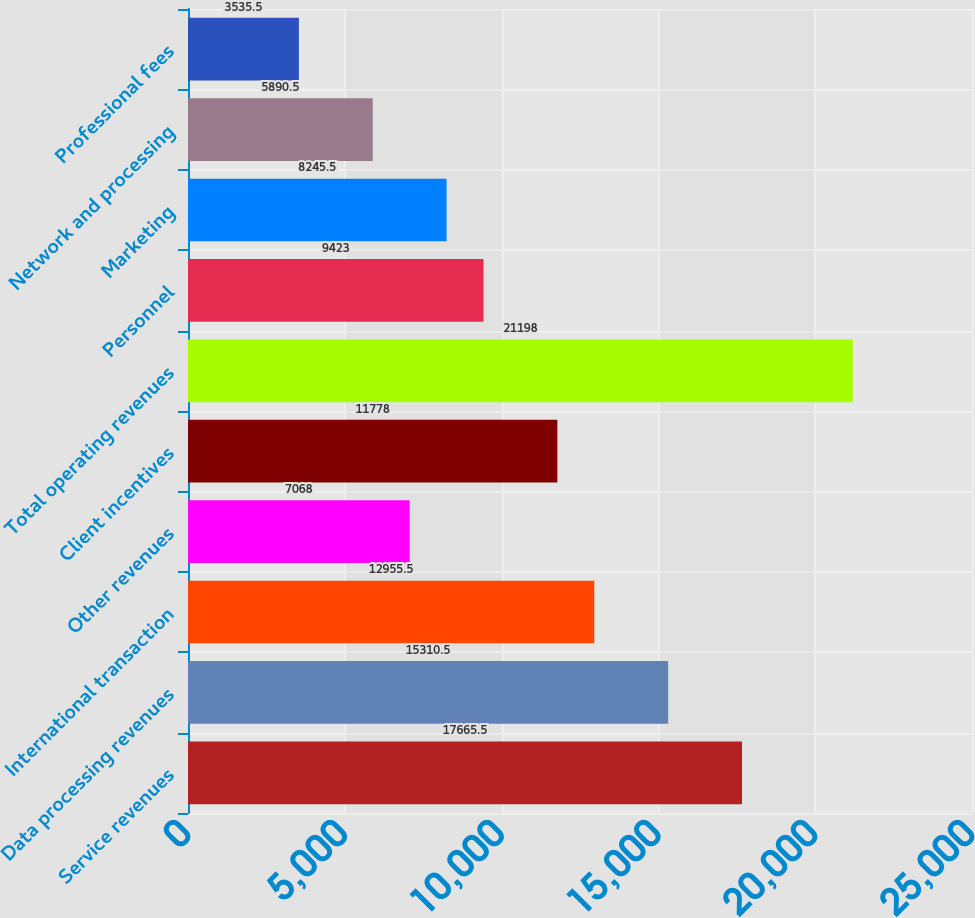Convert chart. <chart><loc_0><loc_0><loc_500><loc_500><bar_chart><fcel>Service revenues<fcel>Data processing revenues<fcel>International transaction<fcel>Other revenues<fcel>Client incentives<fcel>Total operating revenues<fcel>Personnel<fcel>Marketing<fcel>Network and processing<fcel>Professional fees<nl><fcel>17665.5<fcel>15310.5<fcel>12955.5<fcel>7068<fcel>11778<fcel>21198<fcel>9423<fcel>8245.5<fcel>5890.5<fcel>3535.5<nl></chart> 